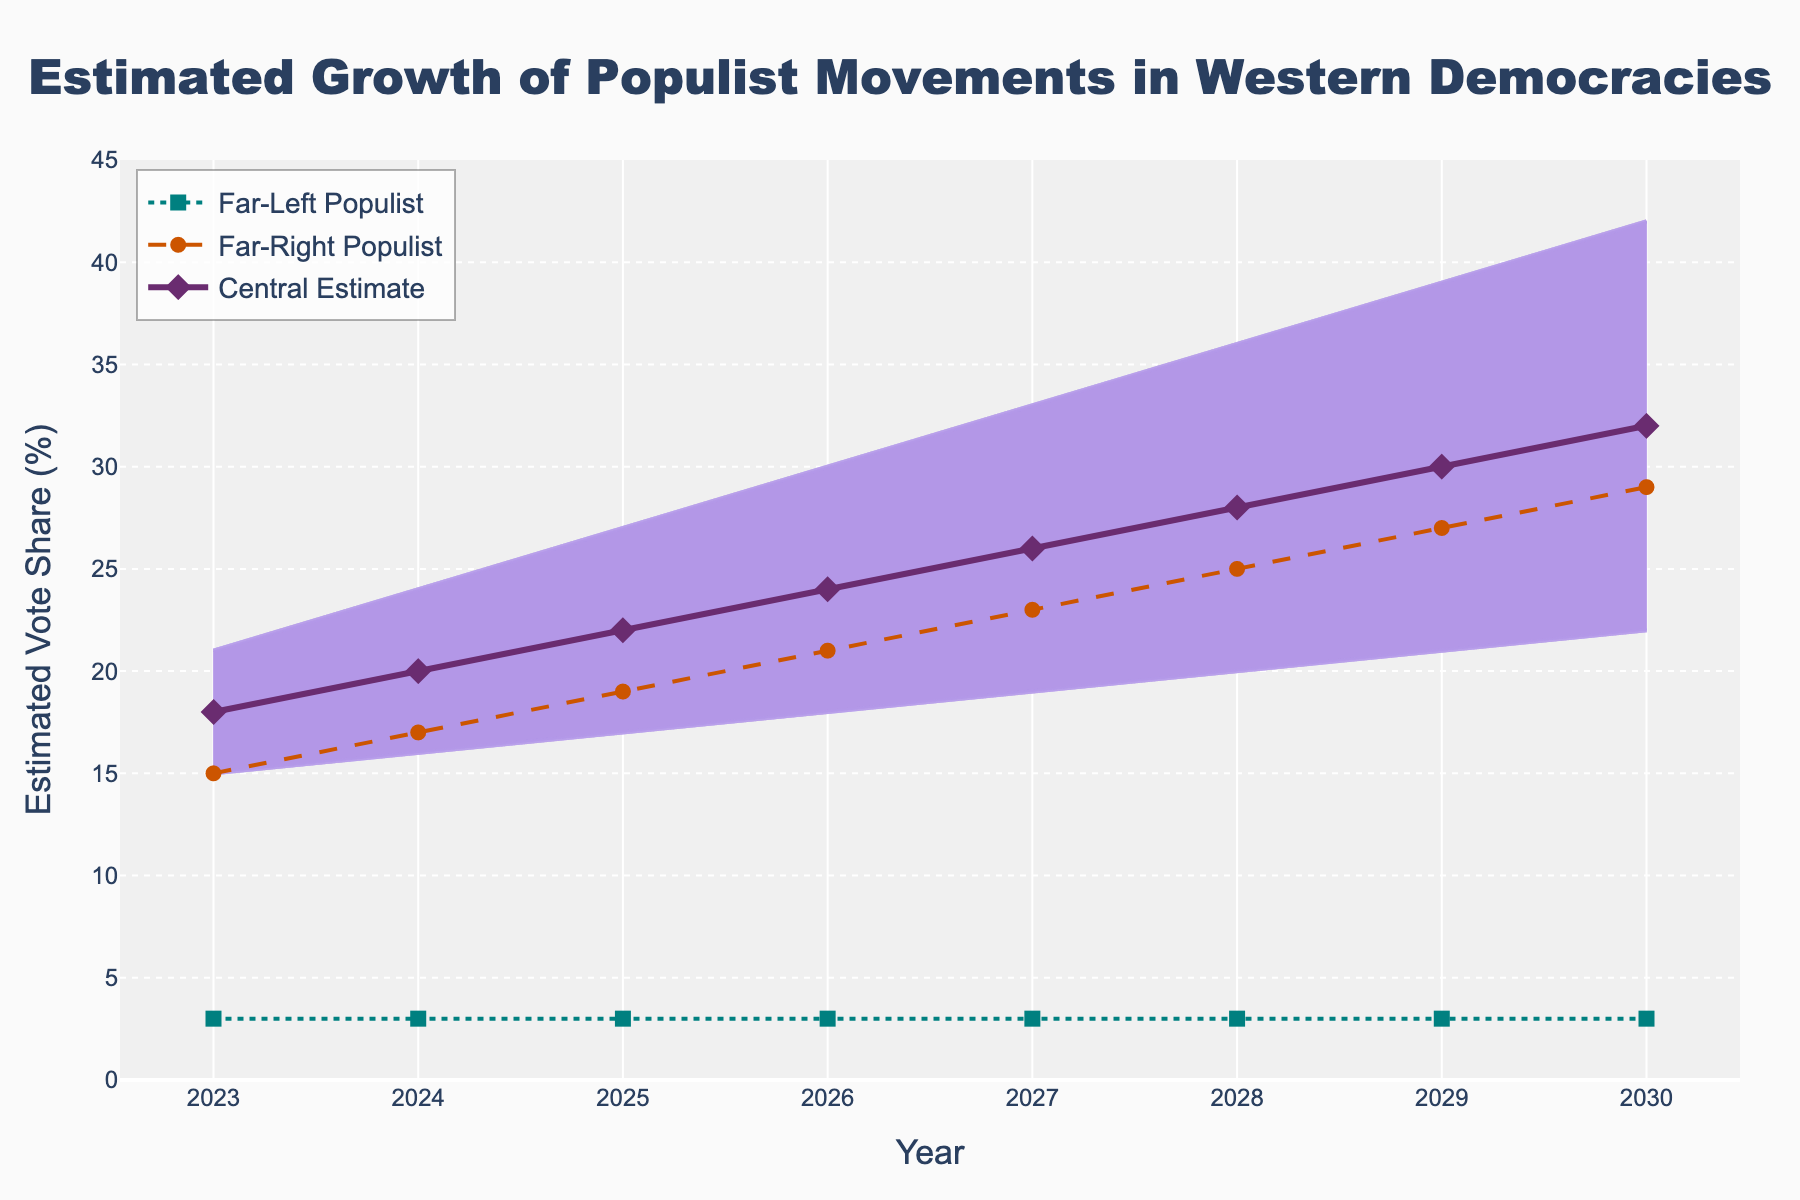What is the range of the estimated vote share for populist movements in 2023? The range is the difference between the upper bound and lower bound values for 2023. Here, the upper bound is 21% and the lower bound is 15%. So, 21 - 15 = 6.
Answer: 6% What trend can be observed in the central estimate of populist movements' vote share from 2023 to 2030? The central estimate consistently increases each year from 18% in 2023 to 32% in 2030, showing a clear upward trend.
Answer: Upward trend How do the estimated vote shares of far-right and far-left populists compare in 2025? In 2025, the estimated vote share for far-right populists is 19%, and for far-left populists, it is 3%. So, far-right populists have a significantly higher estimate.
Answer: Far-right is higher What is the difference between the upper bound and lower bound of the estimated vote share in 2027? The upper bound in 2027 is 33% and the lower bound is 19%. So, the difference is 33 - 19 = 14.
Answer: 14 Which year has the highest central estimate for populist vote share? By inspecting the central estimate values on the figure, we see that 2030 has the highest value at 32%.
Answer: 2030 What can be inferred about the vote share of far-left populists over the years 2023 to 2030? The vote share of far-left populists remains constant at 3% each year from 2023 to 2030.
Answer: Constant Are the upper and lower bounds of estimated vote shares narrowing or widening over time? From 2023 to 2030, the gap between the upper and lower bounds increases, indicating that the range of estimates is widening over time.
Answer: Widening Between what years does the far-right populist vote share increase by 10%? The far-right populist vote share increases from 17% in 2024 to 27% in 2029, a rise of 10%.
Answer: 2024 to 2029 How much does the central estimate of populist votes increase from 2023 to 2028? The central estimate increases from 18% in 2023 to 28% in 2028. Thus, 28 - 18 = 10.
Answer: 10% Which year shows the smallest difference between the upper and lower bounds, and what is it? In 2023, the difference is 6% (21% - 15%), which is the smallest when compared to other years.
Answer: 2023, 6% 